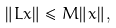Convert formula to latex. <formula><loc_0><loc_0><loc_500><loc_500>\| L x \| \leq M \| x \| ,</formula> 